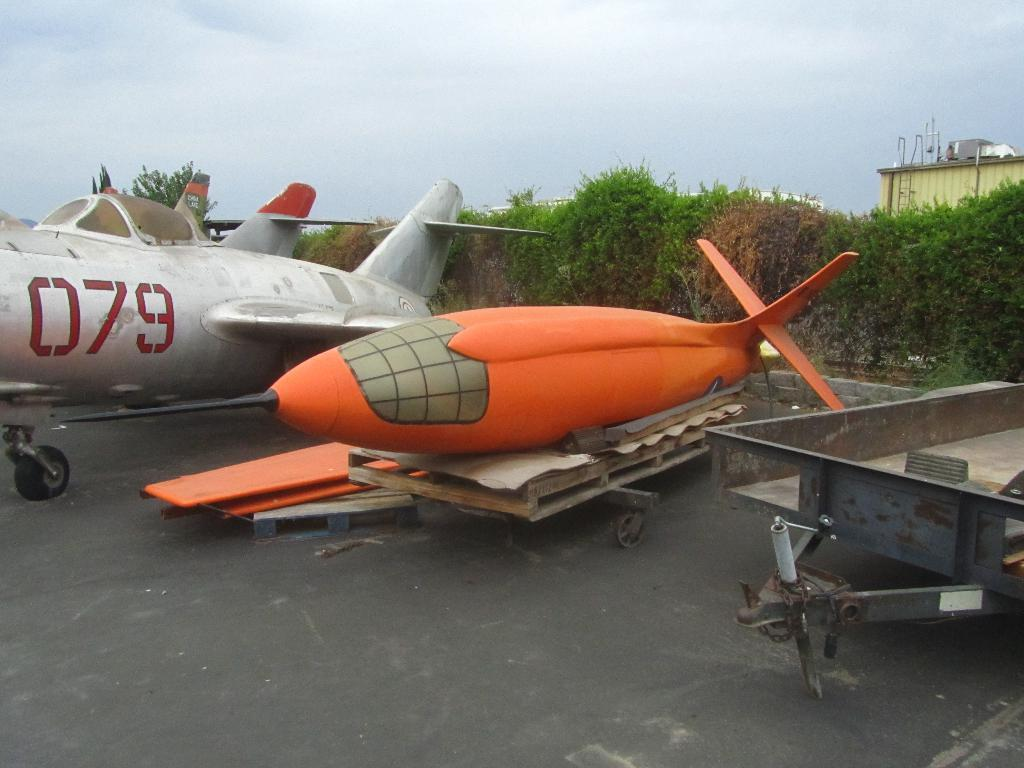Provide a one-sentence caption for the provided image. A small orange aircraft that has its wings detached is laying on a trailer next to a plane with the numbers 079 on it. 